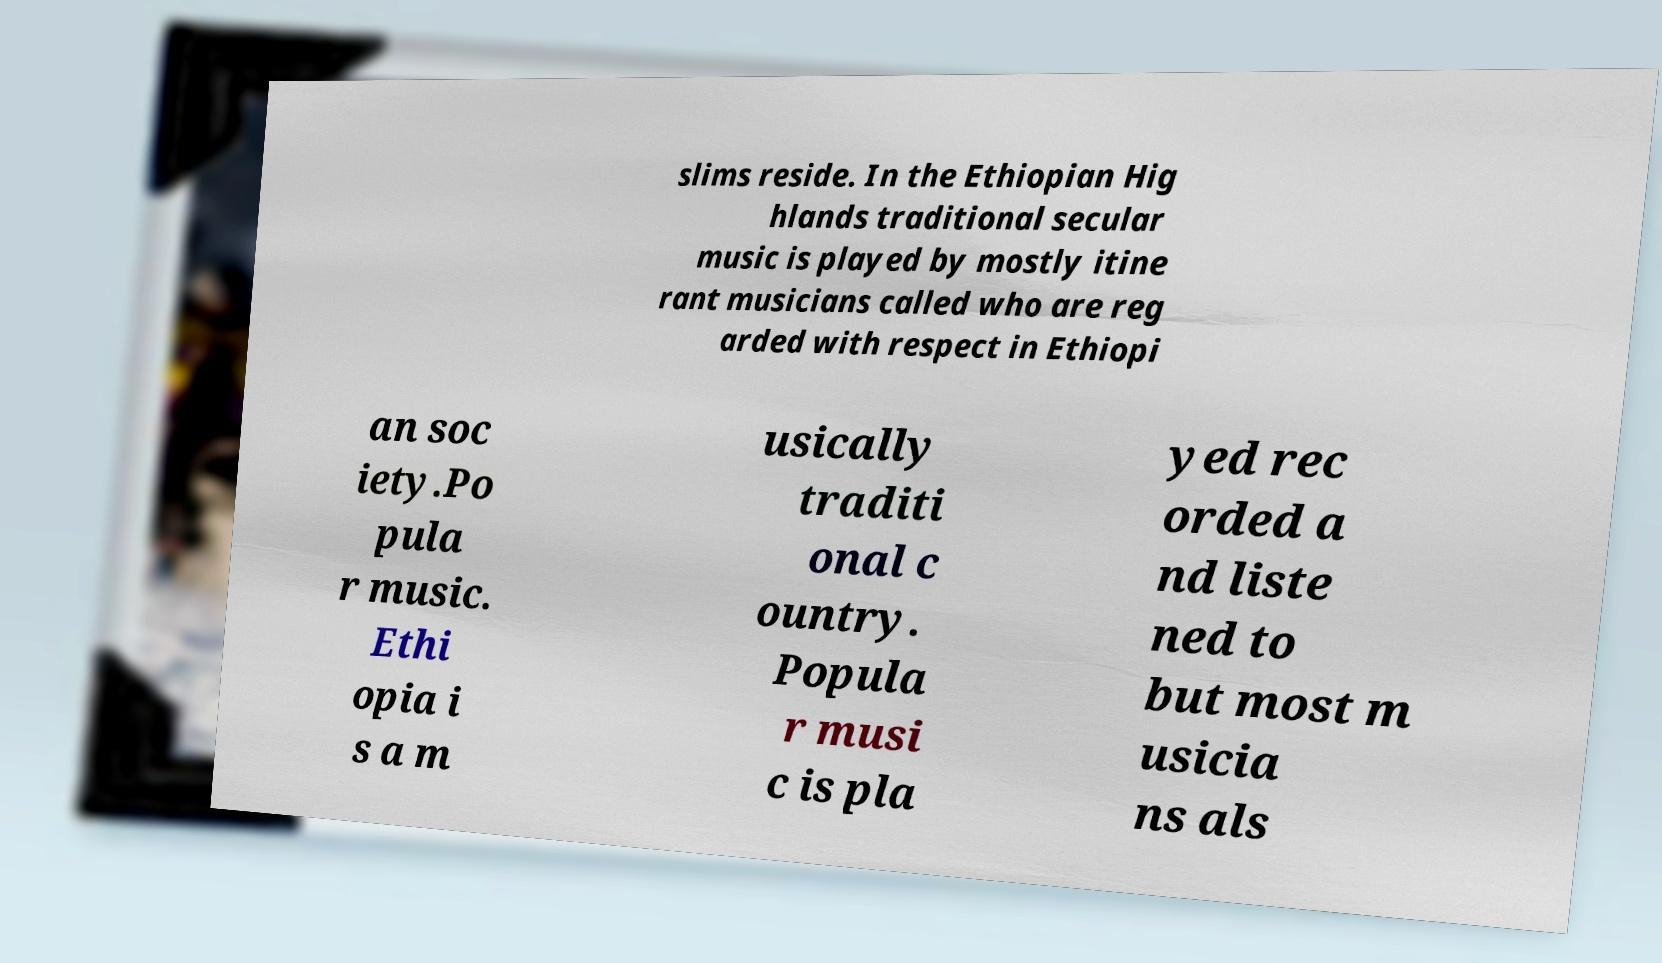Please read and relay the text visible in this image. What does it say? slims reside. In the Ethiopian Hig hlands traditional secular music is played by mostly itine rant musicians called who are reg arded with respect in Ethiopi an soc iety.Po pula r music. Ethi opia i s a m usically traditi onal c ountry. Popula r musi c is pla yed rec orded a nd liste ned to but most m usicia ns als 